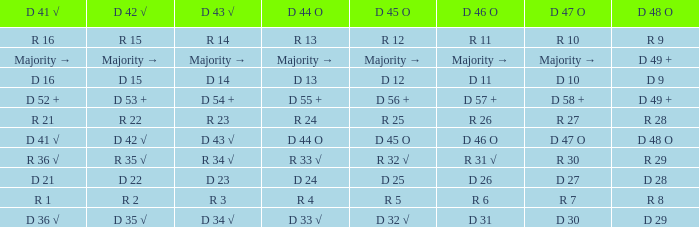Give me the full table as a dictionary. {'header': ['D 41 √', 'D 42 √', 'D 43 √', 'D 44 O', 'D 45 O', 'D 46 O', 'D 47 O', 'D 48 O'], 'rows': [['R 16', 'R 15', 'R 14', 'R 13', 'R 12', 'R 11', 'R 10', 'R 9'], ['Majority →', 'Majority →', 'Majority →', 'Majority →', 'Majority →', 'Majority →', 'Majority →', 'D 49 +'], ['D 16', 'D 15', 'D 14', 'D 13', 'D 12', 'D 11', 'D 10', 'D 9'], ['D 52 +', 'D 53 +', 'D 54 +', 'D 55 +', 'D 56 +', 'D 57 +', 'D 58 +', 'D 49 +'], ['R 21', 'R 22', 'R 23', 'R 24', 'R 25', 'R 26', 'R 27', 'R 28'], ['D 41 √', 'D 42 √', 'D 43 √', 'D 44 O', 'D 45 O', 'D 46 O', 'D 47 O', 'D 48 O'], ['R 36 √', 'R 35 √', 'R 34 √', 'R 33 √', 'R 32 √', 'R 31 √', 'R 30', 'R 29'], ['D 21', 'D 22', 'D 23', 'D 24', 'D 25', 'D 26', 'D 27', 'D 28'], ['R 1', 'R 2', 'R 3', 'R 4', 'R 5', 'R 6', 'R 7', 'R 8'], ['D 36 √', 'D 35 √', 'D 34 √', 'D 33 √', 'D 32 √', 'D 31', 'D 30', 'D 29']]} Name the D 47 O with D 48 O of r 9 R 10. 